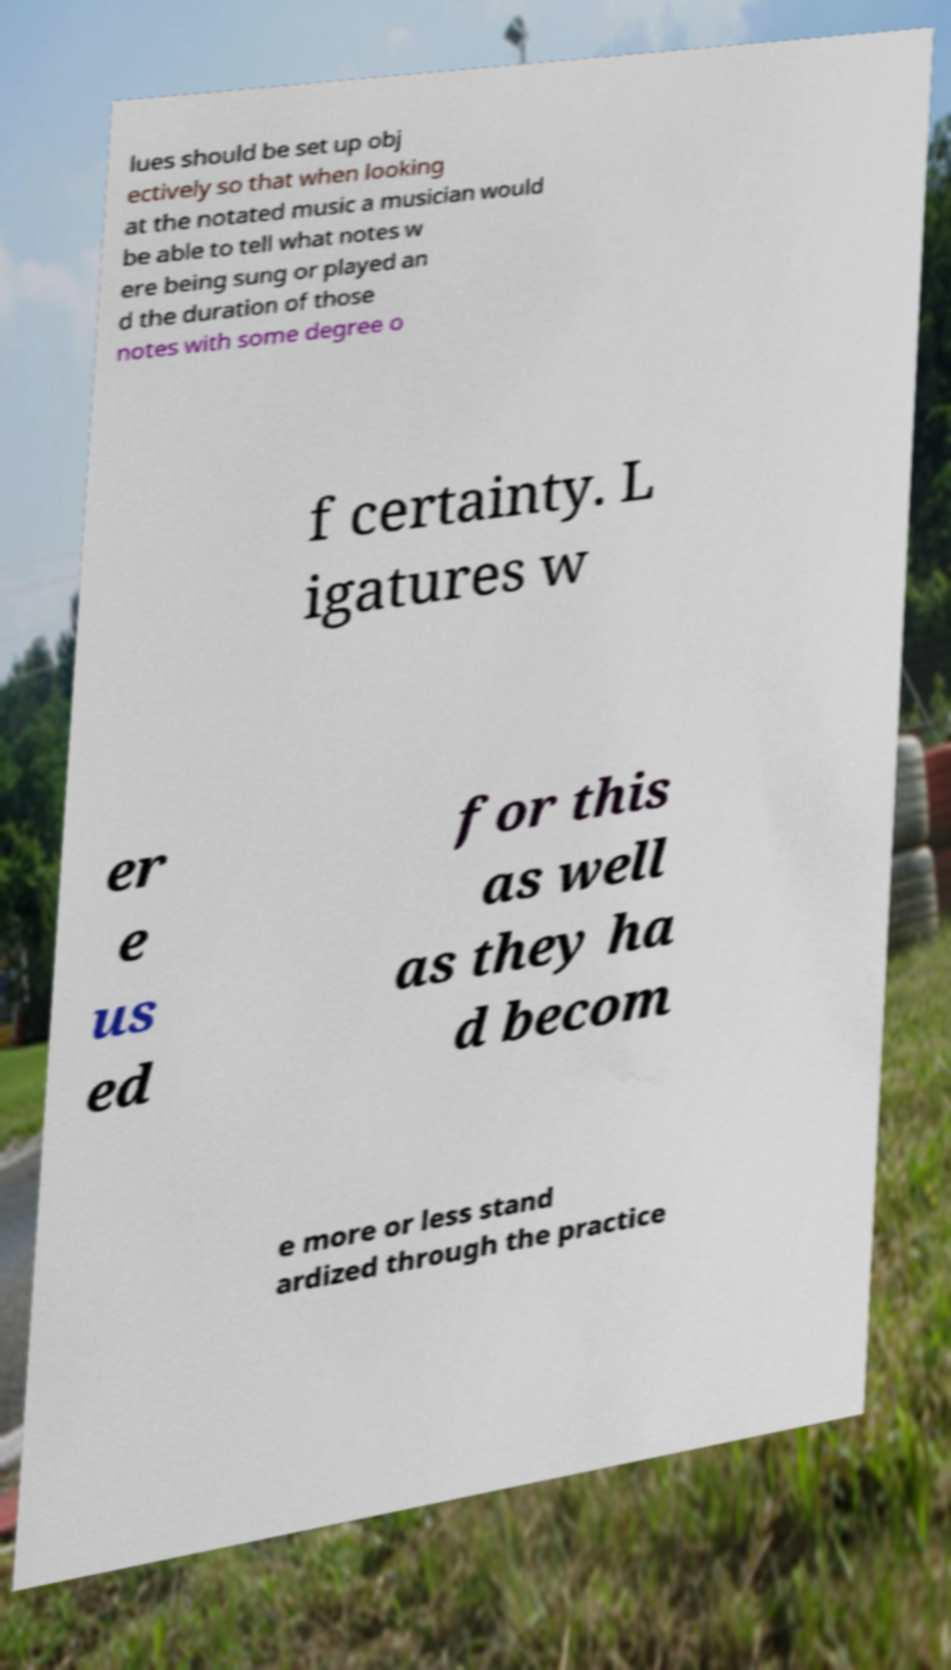Could you assist in decoding the text presented in this image and type it out clearly? lues should be set up obj ectively so that when looking at the notated music a musician would be able to tell what notes w ere being sung or played an d the duration of those notes with some degree o f certainty. L igatures w er e us ed for this as well as they ha d becom e more or less stand ardized through the practice 